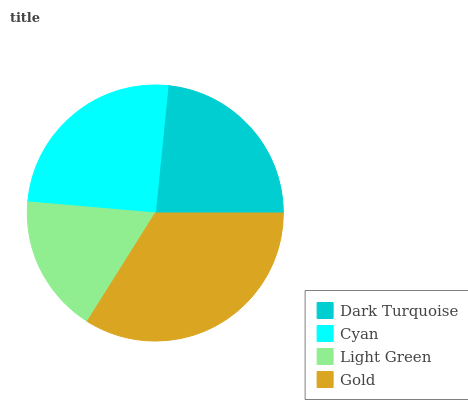Is Light Green the minimum?
Answer yes or no. Yes. Is Gold the maximum?
Answer yes or no. Yes. Is Cyan the minimum?
Answer yes or no. No. Is Cyan the maximum?
Answer yes or no. No. Is Cyan greater than Dark Turquoise?
Answer yes or no. Yes. Is Dark Turquoise less than Cyan?
Answer yes or no. Yes. Is Dark Turquoise greater than Cyan?
Answer yes or no. No. Is Cyan less than Dark Turquoise?
Answer yes or no. No. Is Cyan the high median?
Answer yes or no. Yes. Is Dark Turquoise the low median?
Answer yes or no. Yes. Is Dark Turquoise the high median?
Answer yes or no. No. Is Light Green the low median?
Answer yes or no. No. 